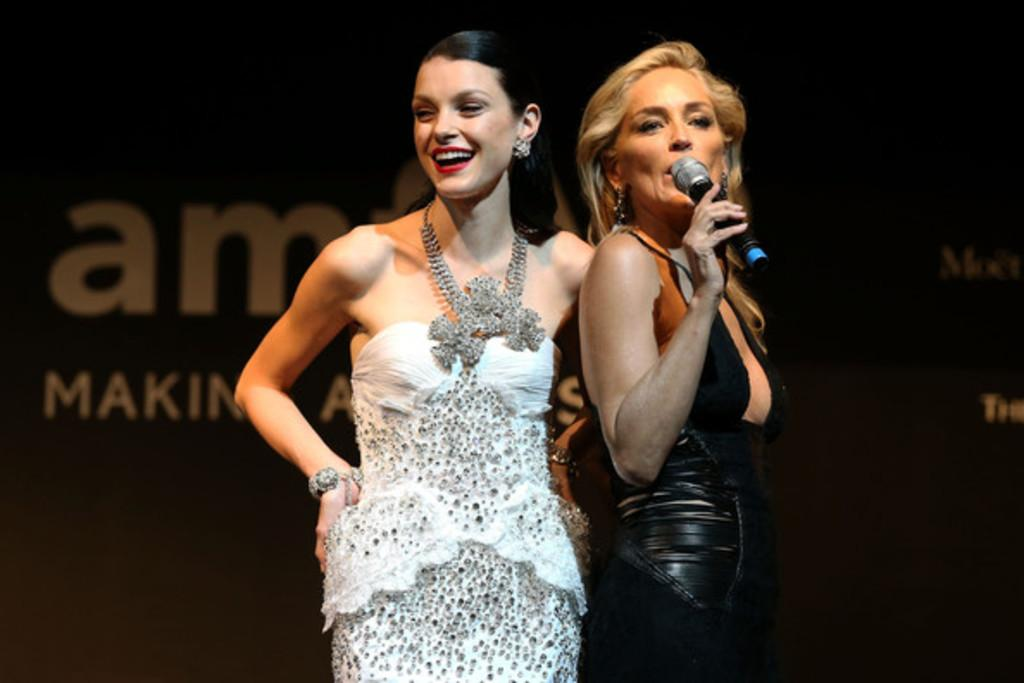How many women are present in the image? There are two women in the image. What are the women doing in the image? One woman is standing, and the other woman is singing a song in the microphone. What type of pollution is being caused by the women in the image? There is no indication of pollution in the image; it features two women, one of whom is singing in a microphone. 